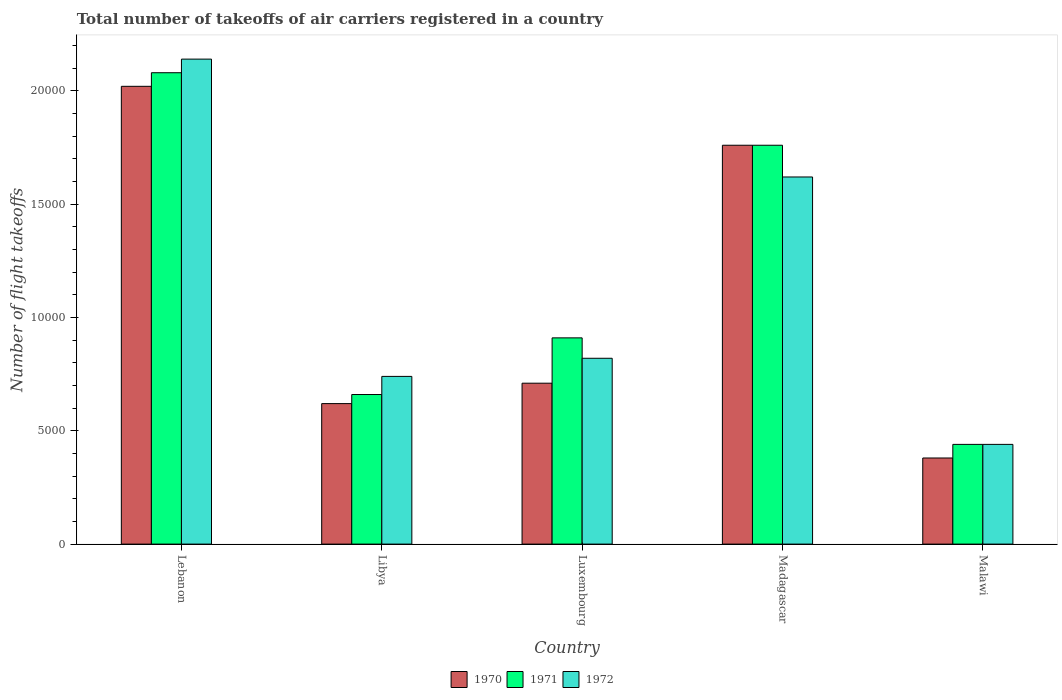How many different coloured bars are there?
Ensure brevity in your answer.  3. Are the number of bars per tick equal to the number of legend labels?
Make the answer very short. Yes. Are the number of bars on each tick of the X-axis equal?
Ensure brevity in your answer.  Yes. How many bars are there on the 4th tick from the left?
Offer a very short reply. 3. What is the label of the 5th group of bars from the left?
Your answer should be very brief. Malawi. What is the total number of flight takeoffs in 1971 in Malawi?
Your answer should be compact. 4400. Across all countries, what is the maximum total number of flight takeoffs in 1971?
Your response must be concise. 2.08e+04. Across all countries, what is the minimum total number of flight takeoffs in 1971?
Keep it short and to the point. 4400. In which country was the total number of flight takeoffs in 1970 maximum?
Provide a short and direct response. Lebanon. In which country was the total number of flight takeoffs in 1972 minimum?
Ensure brevity in your answer.  Malawi. What is the total total number of flight takeoffs in 1972 in the graph?
Your answer should be compact. 5.76e+04. What is the difference between the total number of flight takeoffs in 1972 in Lebanon and that in Luxembourg?
Offer a very short reply. 1.32e+04. What is the difference between the total number of flight takeoffs in 1972 in Lebanon and the total number of flight takeoffs in 1971 in Malawi?
Offer a very short reply. 1.70e+04. What is the average total number of flight takeoffs in 1970 per country?
Ensure brevity in your answer.  1.10e+04. What is the difference between the total number of flight takeoffs of/in 1972 and total number of flight takeoffs of/in 1970 in Madagascar?
Give a very brief answer. -1400. In how many countries, is the total number of flight takeoffs in 1971 greater than 21000?
Make the answer very short. 0. What is the ratio of the total number of flight takeoffs in 1970 in Lebanon to that in Madagascar?
Your answer should be very brief. 1.15. Is the total number of flight takeoffs in 1972 in Lebanon less than that in Luxembourg?
Your answer should be compact. No. What is the difference between the highest and the second highest total number of flight takeoffs in 1972?
Make the answer very short. 1.32e+04. What is the difference between the highest and the lowest total number of flight takeoffs in 1972?
Offer a very short reply. 1.70e+04. Is the sum of the total number of flight takeoffs in 1971 in Luxembourg and Madagascar greater than the maximum total number of flight takeoffs in 1972 across all countries?
Give a very brief answer. Yes. Is it the case that in every country, the sum of the total number of flight takeoffs in 1972 and total number of flight takeoffs in 1971 is greater than the total number of flight takeoffs in 1970?
Offer a terse response. Yes. What is the difference between two consecutive major ticks on the Y-axis?
Your response must be concise. 5000. Are the values on the major ticks of Y-axis written in scientific E-notation?
Give a very brief answer. No. Does the graph contain grids?
Your answer should be compact. No. How many legend labels are there?
Ensure brevity in your answer.  3. How are the legend labels stacked?
Provide a short and direct response. Horizontal. What is the title of the graph?
Provide a succinct answer. Total number of takeoffs of air carriers registered in a country. What is the label or title of the X-axis?
Ensure brevity in your answer.  Country. What is the label or title of the Y-axis?
Give a very brief answer. Number of flight takeoffs. What is the Number of flight takeoffs in 1970 in Lebanon?
Your answer should be very brief. 2.02e+04. What is the Number of flight takeoffs of 1971 in Lebanon?
Your answer should be compact. 2.08e+04. What is the Number of flight takeoffs in 1972 in Lebanon?
Your response must be concise. 2.14e+04. What is the Number of flight takeoffs of 1970 in Libya?
Your answer should be very brief. 6200. What is the Number of flight takeoffs of 1971 in Libya?
Provide a succinct answer. 6600. What is the Number of flight takeoffs in 1972 in Libya?
Keep it short and to the point. 7400. What is the Number of flight takeoffs of 1970 in Luxembourg?
Your answer should be compact. 7100. What is the Number of flight takeoffs of 1971 in Luxembourg?
Provide a short and direct response. 9100. What is the Number of flight takeoffs of 1972 in Luxembourg?
Give a very brief answer. 8200. What is the Number of flight takeoffs of 1970 in Madagascar?
Your answer should be very brief. 1.76e+04. What is the Number of flight takeoffs of 1971 in Madagascar?
Offer a terse response. 1.76e+04. What is the Number of flight takeoffs of 1972 in Madagascar?
Your answer should be compact. 1.62e+04. What is the Number of flight takeoffs of 1970 in Malawi?
Your answer should be compact. 3800. What is the Number of flight takeoffs of 1971 in Malawi?
Give a very brief answer. 4400. What is the Number of flight takeoffs of 1972 in Malawi?
Ensure brevity in your answer.  4400. Across all countries, what is the maximum Number of flight takeoffs in 1970?
Give a very brief answer. 2.02e+04. Across all countries, what is the maximum Number of flight takeoffs in 1971?
Offer a terse response. 2.08e+04. Across all countries, what is the maximum Number of flight takeoffs of 1972?
Provide a succinct answer. 2.14e+04. Across all countries, what is the minimum Number of flight takeoffs in 1970?
Keep it short and to the point. 3800. Across all countries, what is the minimum Number of flight takeoffs in 1971?
Provide a short and direct response. 4400. Across all countries, what is the minimum Number of flight takeoffs in 1972?
Ensure brevity in your answer.  4400. What is the total Number of flight takeoffs of 1970 in the graph?
Offer a terse response. 5.49e+04. What is the total Number of flight takeoffs in 1971 in the graph?
Ensure brevity in your answer.  5.85e+04. What is the total Number of flight takeoffs in 1972 in the graph?
Offer a very short reply. 5.76e+04. What is the difference between the Number of flight takeoffs in 1970 in Lebanon and that in Libya?
Your response must be concise. 1.40e+04. What is the difference between the Number of flight takeoffs of 1971 in Lebanon and that in Libya?
Your answer should be compact. 1.42e+04. What is the difference between the Number of flight takeoffs of 1972 in Lebanon and that in Libya?
Make the answer very short. 1.40e+04. What is the difference between the Number of flight takeoffs in 1970 in Lebanon and that in Luxembourg?
Your answer should be very brief. 1.31e+04. What is the difference between the Number of flight takeoffs of 1971 in Lebanon and that in Luxembourg?
Keep it short and to the point. 1.17e+04. What is the difference between the Number of flight takeoffs in 1972 in Lebanon and that in Luxembourg?
Your response must be concise. 1.32e+04. What is the difference between the Number of flight takeoffs in 1970 in Lebanon and that in Madagascar?
Keep it short and to the point. 2600. What is the difference between the Number of flight takeoffs in 1971 in Lebanon and that in Madagascar?
Ensure brevity in your answer.  3200. What is the difference between the Number of flight takeoffs in 1972 in Lebanon and that in Madagascar?
Keep it short and to the point. 5200. What is the difference between the Number of flight takeoffs in 1970 in Lebanon and that in Malawi?
Your answer should be compact. 1.64e+04. What is the difference between the Number of flight takeoffs of 1971 in Lebanon and that in Malawi?
Ensure brevity in your answer.  1.64e+04. What is the difference between the Number of flight takeoffs of 1972 in Lebanon and that in Malawi?
Your answer should be compact. 1.70e+04. What is the difference between the Number of flight takeoffs in 1970 in Libya and that in Luxembourg?
Offer a terse response. -900. What is the difference between the Number of flight takeoffs in 1971 in Libya and that in Luxembourg?
Your answer should be compact. -2500. What is the difference between the Number of flight takeoffs in 1972 in Libya and that in Luxembourg?
Provide a succinct answer. -800. What is the difference between the Number of flight takeoffs in 1970 in Libya and that in Madagascar?
Offer a terse response. -1.14e+04. What is the difference between the Number of flight takeoffs of 1971 in Libya and that in Madagascar?
Keep it short and to the point. -1.10e+04. What is the difference between the Number of flight takeoffs in 1972 in Libya and that in Madagascar?
Your response must be concise. -8800. What is the difference between the Number of flight takeoffs of 1970 in Libya and that in Malawi?
Provide a succinct answer. 2400. What is the difference between the Number of flight takeoffs of 1971 in Libya and that in Malawi?
Give a very brief answer. 2200. What is the difference between the Number of flight takeoffs in 1972 in Libya and that in Malawi?
Ensure brevity in your answer.  3000. What is the difference between the Number of flight takeoffs of 1970 in Luxembourg and that in Madagascar?
Make the answer very short. -1.05e+04. What is the difference between the Number of flight takeoffs of 1971 in Luxembourg and that in Madagascar?
Ensure brevity in your answer.  -8500. What is the difference between the Number of flight takeoffs of 1972 in Luxembourg and that in Madagascar?
Ensure brevity in your answer.  -8000. What is the difference between the Number of flight takeoffs in 1970 in Luxembourg and that in Malawi?
Offer a terse response. 3300. What is the difference between the Number of flight takeoffs of 1971 in Luxembourg and that in Malawi?
Ensure brevity in your answer.  4700. What is the difference between the Number of flight takeoffs in 1972 in Luxembourg and that in Malawi?
Offer a terse response. 3800. What is the difference between the Number of flight takeoffs in 1970 in Madagascar and that in Malawi?
Give a very brief answer. 1.38e+04. What is the difference between the Number of flight takeoffs of 1971 in Madagascar and that in Malawi?
Offer a terse response. 1.32e+04. What is the difference between the Number of flight takeoffs in 1972 in Madagascar and that in Malawi?
Offer a very short reply. 1.18e+04. What is the difference between the Number of flight takeoffs in 1970 in Lebanon and the Number of flight takeoffs in 1971 in Libya?
Make the answer very short. 1.36e+04. What is the difference between the Number of flight takeoffs of 1970 in Lebanon and the Number of flight takeoffs of 1972 in Libya?
Provide a succinct answer. 1.28e+04. What is the difference between the Number of flight takeoffs of 1971 in Lebanon and the Number of flight takeoffs of 1972 in Libya?
Give a very brief answer. 1.34e+04. What is the difference between the Number of flight takeoffs of 1970 in Lebanon and the Number of flight takeoffs of 1971 in Luxembourg?
Ensure brevity in your answer.  1.11e+04. What is the difference between the Number of flight takeoffs of 1970 in Lebanon and the Number of flight takeoffs of 1972 in Luxembourg?
Your response must be concise. 1.20e+04. What is the difference between the Number of flight takeoffs of 1971 in Lebanon and the Number of flight takeoffs of 1972 in Luxembourg?
Offer a terse response. 1.26e+04. What is the difference between the Number of flight takeoffs in 1970 in Lebanon and the Number of flight takeoffs in 1971 in Madagascar?
Provide a succinct answer. 2600. What is the difference between the Number of flight takeoffs of 1970 in Lebanon and the Number of flight takeoffs of 1972 in Madagascar?
Give a very brief answer. 4000. What is the difference between the Number of flight takeoffs in 1971 in Lebanon and the Number of flight takeoffs in 1972 in Madagascar?
Your answer should be very brief. 4600. What is the difference between the Number of flight takeoffs of 1970 in Lebanon and the Number of flight takeoffs of 1971 in Malawi?
Provide a short and direct response. 1.58e+04. What is the difference between the Number of flight takeoffs in 1970 in Lebanon and the Number of flight takeoffs in 1972 in Malawi?
Offer a very short reply. 1.58e+04. What is the difference between the Number of flight takeoffs of 1971 in Lebanon and the Number of flight takeoffs of 1972 in Malawi?
Offer a very short reply. 1.64e+04. What is the difference between the Number of flight takeoffs in 1970 in Libya and the Number of flight takeoffs in 1971 in Luxembourg?
Offer a very short reply. -2900. What is the difference between the Number of flight takeoffs in 1970 in Libya and the Number of flight takeoffs in 1972 in Luxembourg?
Offer a very short reply. -2000. What is the difference between the Number of flight takeoffs in 1971 in Libya and the Number of flight takeoffs in 1972 in Luxembourg?
Provide a succinct answer. -1600. What is the difference between the Number of flight takeoffs in 1970 in Libya and the Number of flight takeoffs in 1971 in Madagascar?
Make the answer very short. -1.14e+04. What is the difference between the Number of flight takeoffs in 1970 in Libya and the Number of flight takeoffs in 1972 in Madagascar?
Keep it short and to the point. -10000. What is the difference between the Number of flight takeoffs of 1971 in Libya and the Number of flight takeoffs of 1972 in Madagascar?
Your answer should be very brief. -9600. What is the difference between the Number of flight takeoffs of 1970 in Libya and the Number of flight takeoffs of 1971 in Malawi?
Offer a terse response. 1800. What is the difference between the Number of flight takeoffs of 1970 in Libya and the Number of flight takeoffs of 1972 in Malawi?
Ensure brevity in your answer.  1800. What is the difference between the Number of flight takeoffs of 1971 in Libya and the Number of flight takeoffs of 1972 in Malawi?
Your answer should be compact. 2200. What is the difference between the Number of flight takeoffs in 1970 in Luxembourg and the Number of flight takeoffs in 1971 in Madagascar?
Your answer should be very brief. -1.05e+04. What is the difference between the Number of flight takeoffs of 1970 in Luxembourg and the Number of flight takeoffs of 1972 in Madagascar?
Make the answer very short. -9100. What is the difference between the Number of flight takeoffs of 1971 in Luxembourg and the Number of flight takeoffs of 1972 in Madagascar?
Offer a very short reply. -7100. What is the difference between the Number of flight takeoffs of 1970 in Luxembourg and the Number of flight takeoffs of 1971 in Malawi?
Your answer should be compact. 2700. What is the difference between the Number of flight takeoffs in 1970 in Luxembourg and the Number of flight takeoffs in 1972 in Malawi?
Keep it short and to the point. 2700. What is the difference between the Number of flight takeoffs in 1971 in Luxembourg and the Number of flight takeoffs in 1972 in Malawi?
Keep it short and to the point. 4700. What is the difference between the Number of flight takeoffs in 1970 in Madagascar and the Number of flight takeoffs in 1971 in Malawi?
Your response must be concise. 1.32e+04. What is the difference between the Number of flight takeoffs in 1970 in Madagascar and the Number of flight takeoffs in 1972 in Malawi?
Your response must be concise. 1.32e+04. What is the difference between the Number of flight takeoffs in 1971 in Madagascar and the Number of flight takeoffs in 1972 in Malawi?
Give a very brief answer. 1.32e+04. What is the average Number of flight takeoffs in 1970 per country?
Make the answer very short. 1.10e+04. What is the average Number of flight takeoffs of 1971 per country?
Offer a terse response. 1.17e+04. What is the average Number of flight takeoffs in 1972 per country?
Keep it short and to the point. 1.15e+04. What is the difference between the Number of flight takeoffs in 1970 and Number of flight takeoffs in 1971 in Lebanon?
Your answer should be very brief. -600. What is the difference between the Number of flight takeoffs of 1970 and Number of flight takeoffs of 1972 in Lebanon?
Your answer should be very brief. -1200. What is the difference between the Number of flight takeoffs in 1971 and Number of flight takeoffs in 1972 in Lebanon?
Provide a succinct answer. -600. What is the difference between the Number of flight takeoffs in 1970 and Number of flight takeoffs in 1971 in Libya?
Make the answer very short. -400. What is the difference between the Number of flight takeoffs in 1970 and Number of flight takeoffs in 1972 in Libya?
Your response must be concise. -1200. What is the difference between the Number of flight takeoffs in 1971 and Number of flight takeoffs in 1972 in Libya?
Offer a very short reply. -800. What is the difference between the Number of flight takeoffs of 1970 and Number of flight takeoffs of 1971 in Luxembourg?
Your answer should be very brief. -2000. What is the difference between the Number of flight takeoffs in 1970 and Number of flight takeoffs in 1972 in Luxembourg?
Offer a terse response. -1100. What is the difference between the Number of flight takeoffs in 1971 and Number of flight takeoffs in 1972 in Luxembourg?
Provide a succinct answer. 900. What is the difference between the Number of flight takeoffs in 1970 and Number of flight takeoffs in 1972 in Madagascar?
Ensure brevity in your answer.  1400. What is the difference between the Number of flight takeoffs of 1971 and Number of flight takeoffs of 1972 in Madagascar?
Your answer should be compact. 1400. What is the difference between the Number of flight takeoffs of 1970 and Number of flight takeoffs of 1971 in Malawi?
Your answer should be very brief. -600. What is the difference between the Number of flight takeoffs in 1970 and Number of flight takeoffs in 1972 in Malawi?
Your answer should be very brief. -600. What is the difference between the Number of flight takeoffs in 1971 and Number of flight takeoffs in 1972 in Malawi?
Offer a terse response. 0. What is the ratio of the Number of flight takeoffs in 1970 in Lebanon to that in Libya?
Provide a succinct answer. 3.26. What is the ratio of the Number of flight takeoffs in 1971 in Lebanon to that in Libya?
Your response must be concise. 3.15. What is the ratio of the Number of flight takeoffs in 1972 in Lebanon to that in Libya?
Offer a terse response. 2.89. What is the ratio of the Number of flight takeoffs of 1970 in Lebanon to that in Luxembourg?
Your answer should be compact. 2.85. What is the ratio of the Number of flight takeoffs in 1971 in Lebanon to that in Luxembourg?
Offer a terse response. 2.29. What is the ratio of the Number of flight takeoffs of 1972 in Lebanon to that in Luxembourg?
Your response must be concise. 2.61. What is the ratio of the Number of flight takeoffs in 1970 in Lebanon to that in Madagascar?
Provide a succinct answer. 1.15. What is the ratio of the Number of flight takeoffs of 1971 in Lebanon to that in Madagascar?
Make the answer very short. 1.18. What is the ratio of the Number of flight takeoffs in 1972 in Lebanon to that in Madagascar?
Provide a succinct answer. 1.32. What is the ratio of the Number of flight takeoffs in 1970 in Lebanon to that in Malawi?
Offer a terse response. 5.32. What is the ratio of the Number of flight takeoffs of 1971 in Lebanon to that in Malawi?
Make the answer very short. 4.73. What is the ratio of the Number of flight takeoffs of 1972 in Lebanon to that in Malawi?
Offer a very short reply. 4.86. What is the ratio of the Number of flight takeoffs in 1970 in Libya to that in Luxembourg?
Your answer should be compact. 0.87. What is the ratio of the Number of flight takeoffs in 1971 in Libya to that in Luxembourg?
Your response must be concise. 0.73. What is the ratio of the Number of flight takeoffs in 1972 in Libya to that in Luxembourg?
Ensure brevity in your answer.  0.9. What is the ratio of the Number of flight takeoffs of 1970 in Libya to that in Madagascar?
Your response must be concise. 0.35. What is the ratio of the Number of flight takeoffs of 1972 in Libya to that in Madagascar?
Your answer should be compact. 0.46. What is the ratio of the Number of flight takeoffs of 1970 in Libya to that in Malawi?
Offer a very short reply. 1.63. What is the ratio of the Number of flight takeoffs in 1971 in Libya to that in Malawi?
Ensure brevity in your answer.  1.5. What is the ratio of the Number of flight takeoffs of 1972 in Libya to that in Malawi?
Provide a short and direct response. 1.68. What is the ratio of the Number of flight takeoffs in 1970 in Luxembourg to that in Madagascar?
Give a very brief answer. 0.4. What is the ratio of the Number of flight takeoffs in 1971 in Luxembourg to that in Madagascar?
Your answer should be very brief. 0.52. What is the ratio of the Number of flight takeoffs of 1972 in Luxembourg to that in Madagascar?
Make the answer very short. 0.51. What is the ratio of the Number of flight takeoffs in 1970 in Luxembourg to that in Malawi?
Keep it short and to the point. 1.87. What is the ratio of the Number of flight takeoffs of 1971 in Luxembourg to that in Malawi?
Provide a succinct answer. 2.07. What is the ratio of the Number of flight takeoffs in 1972 in Luxembourg to that in Malawi?
Give a very brief answer. 1.86. What is the ratio of the Number of flight takeoffs of 1970 in Madagascar to that in Malawi?
Your answer should be compact. 4.63. What is the ratio of the Number of flight takeoffs of 1972 in Madagascar to that in Malawi?
Ensure brevity in your answer.  3.68. What is the difference between the highest and the second highest Number of flight takeoffs in 1970?
Offer a very short reply. 2600. What is the difference between the highest and the second highest Number of flight takeoffs in 1971?
Your answer should be compact. 3200. What is the difference between the highest and the second highest Number of flight takeoffs in 1972?
Provide a succinct answer. 5200. What is the difference between the highest and the lowest Number of flight takeoffs of 1970?
Offer a very short reply. 1.64e+04. What is the difference between the highest and the lowest Number of flight takeoffs in 1971?
Offer a very short reply. 1.64e+04. What is the difference between the highest and the lowest Number of flight takeoffs of 1972?
Offer a very short reply. 1.70e+04. 